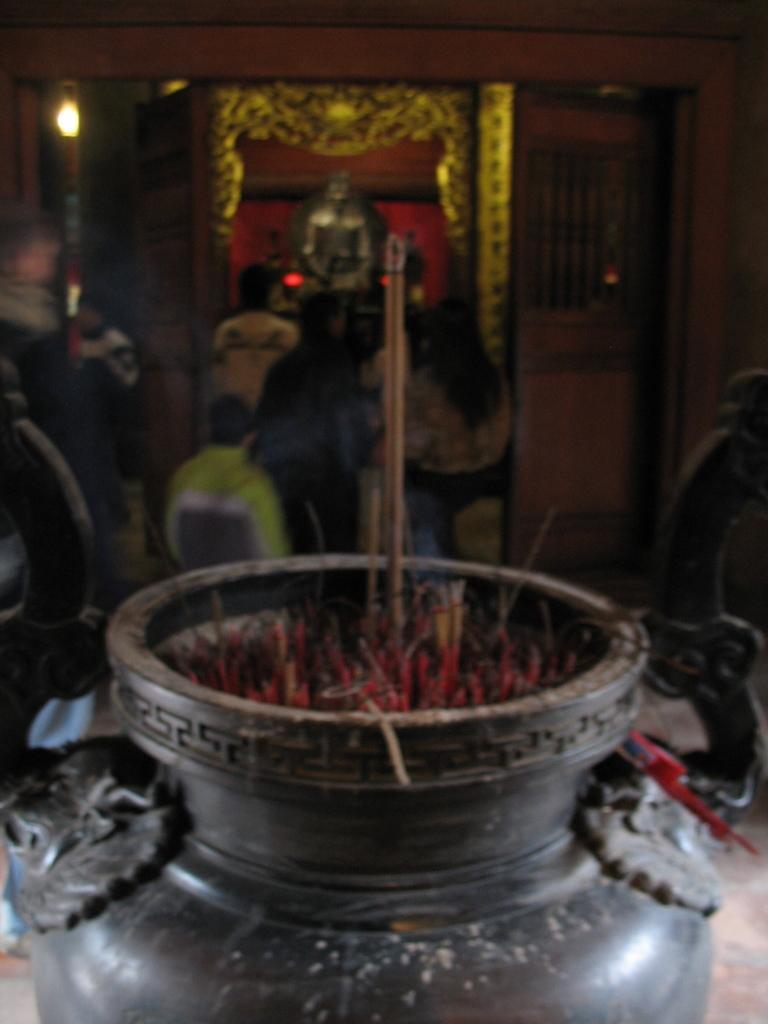In one or two sentences, can you explain what this image depicts? In this picture there are incense sticks in the object. At the back there are group of people standing and there is a statue and there is a light and door. 